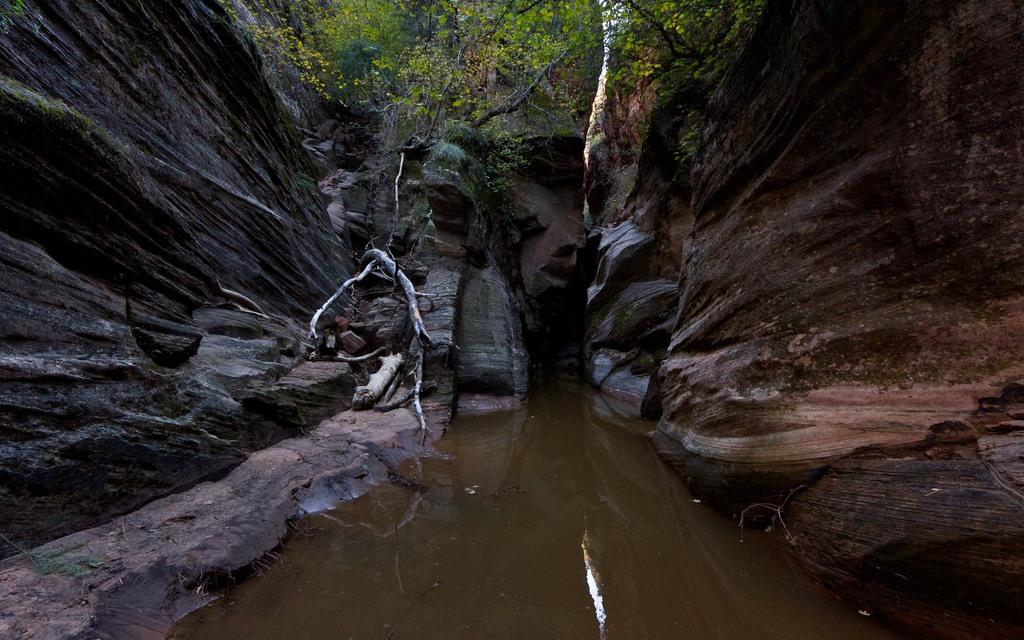What is the primary element visible in the image? There is water in the image. What can be seen above the water in the image? There is a tree at the top of the image. What surrounds the water in the image? There are hills on either side of the water in the image. How many trucks can be seen driving through the water in the image? There are no trucks visible in the image; it features water, a tree, and hills. 